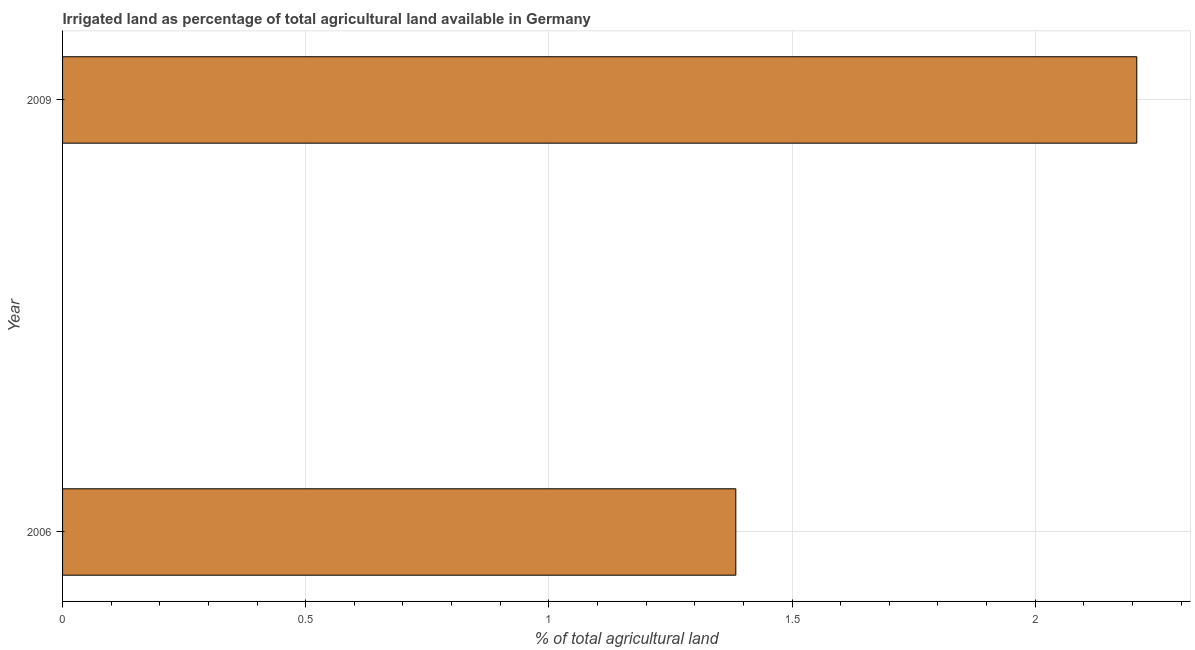Does the graph contain any zero values?
Offer a very short reply. No. What is the title of the graph?
Make the answer very short. Irrigated land as percentage of total agricultural land available in Germany. What is the label or title of the X-axis?
Ensure brevity in your answer.  % of total agricultural land. What is the label or title of the Y-axis?
Provide a succinct answer. Year. What is the percentage of agricultural irrigated land in 2006?
Make the answer very short. 1.38. Across all years, what is the maximum percentage of agricultural irrigated land?
Give a very brief answer. 2.21. Across all years, what is the minimum percentage of agricultural irrigated land?
Your answer should be compact. 1.38. In which year was the percentage of agricultural irrigated land maximum?
Your response must be concise. 2009. In which year was the percentage of agricultural irrigated land minimum?
Give a very brief answer. 2006. What is the sum of the percentage of agricultural irrigated land?
Your answer should be compact. 3.59. What is the difference between the percentage of agricultural irrigated land in 2006 and 2009?
Provide a succinct answer. -0.82. What is the average percentage of agricultural irrigated land per year?
Your answer should be very brief. 1.8. What is the median percentage of agricultural irrigated land?
Your answer should be compact. 1.8. Do a majority of the years between 2009 and 2006 (inclusive) have percentage of agricultural irrigated land greater than 1.2 %?
Offer a terse response. No. What is the ratio of the percentage of agricultural irrigated land in 2006 to that in 2009?
Give a very brief answer. 0.63. Is the percentage of agricultural irrigated land in 2006 less than that in 2009?
Offer a very short reply. Yes. Are all the bars in the graph horizontal?
Your response must be concise. Yes. How many years are there in the graph?
Make the answer very short. 2. Are the values on the major ticks of X-axis written in scientific E-notation?
Make the answer very short. No. What is the % of total agricultural land in 2006?
Provide a succinct answer. 1.38. What is the % of total agricultural land of 2009?
Make the answer very short. 2.21. What is the difference between the % of total agricultural land in 2006 and 2009?
Provide a short and direct response. -0.82. What is the ratio of the % of total agricultural land in 2006 to that in 2009?
Your answer should be very brief. 0.63. 